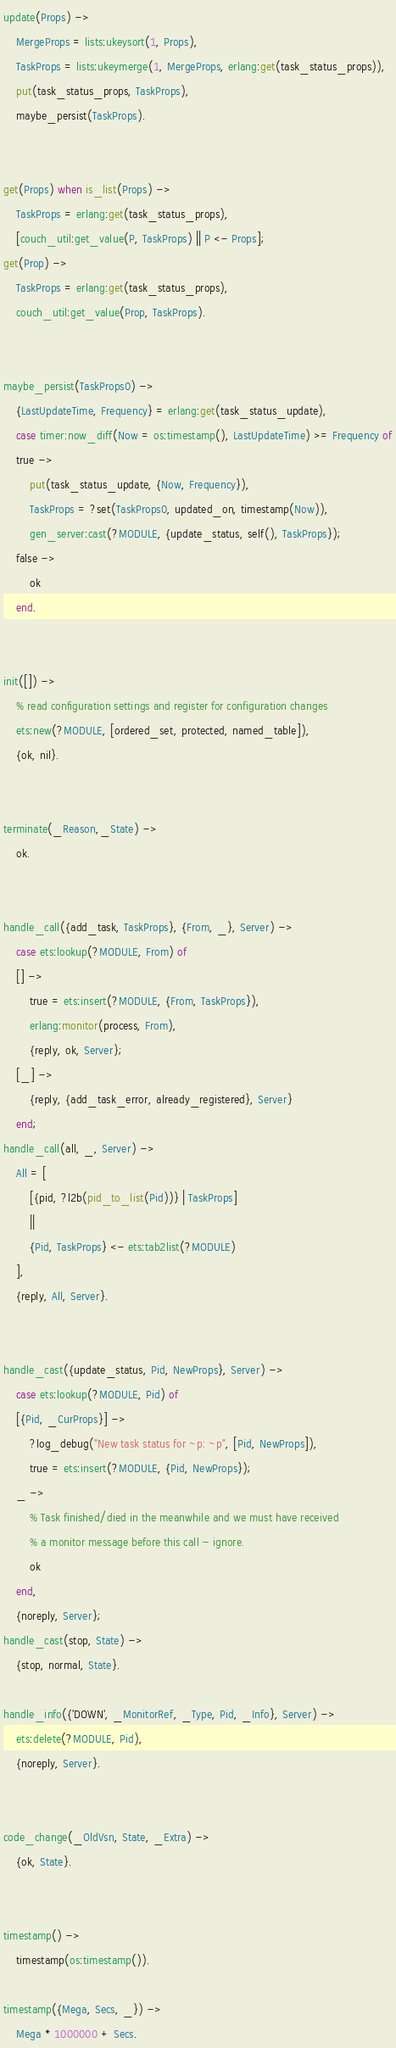<code> <loc_0><loc_0><loc_500><loc_500><_Erlang_>

update(Props) ->
    MergeProps = lists:ukeysort(1, Props),
    TaskProps = lists:ukeymerge(1, MergeProps, erlang:get(task_status_props)),
    put(task_status_props, TaskProps),
    maybe_persist(TaskProps).


get(Props) when is_list(Props) ->
    TaskProps = erlang:get(task_status_props),
    [couch_util:get_value(P, TaskProps) || P <- Props];
get(Prop) ->
    TaskProps = erlang:get(task_status_props),
    couch_util:get_value(Prop, TaskProps).


maybe_persist(TaskProps0) ->
    {LastUpdateTime, Frequency} = erlang:get(task_status_update),
    case timer:now_diff(Now = os:timestamp(), LastUpdateTime) >= Frequency of
    true ->
        put(task_status_update, {Now, Frequency}),
        TaskProps = ?set(TaskProps0, updated_on, timestamp(Now)),
        gen_server:cast(?MODULE, {update_status, self(), TaskProps});
    false ->
        ok
    end.


init([]) ->
    % read configuration settings and register for configuration changes
    ets:new(?MODULE, [ordered_set, protected, named_table]),
    {ok, nil}.


terminate(_Reason,_State) ->
    ok.


handle_call({add_task, TaskProps}, {From, _}, Server) ->
    case ets:lookup(?MODULE, From) of
    [] ->
        true = ets:insert(?MODULE, {From, TaskProps}),
        erlang:monitor(process, From),
        {reply, ok, Server};
    [_] ->
        {reply, {add_task_error, already_registered}, Server}
    end;
handle_call(all, _, Server) ->
    All = [
        [{pid, ?l2b(pid_to_list(Pid))} | TaskProps]
        ||
        {Pid, TaskProps} <- ets:tab2list(?MODULE)
    ],
    {reply, All, Server}.


handle_cast({update_status, Pid, NewProps}, Server) ->
    case ets:lookup(?MODULE, Pid) of
    [{Pid, _CurProps}] ->
        ?log_debug("New task status for ~p: ~p", [Pid, NewProps]),
        true = ets:insert(?MODULE, {Pid, NewProps});
    _ ->
        % Task finished/died in the meanwhile and we must have received
        % a monitor message before this call - ignore.
        ok
    end,
    {noreply, Server};
handle_cast(stop, State) ->
    {stop, normal, State}.

handle_info({'DOWN', _MonitorRef, _Type, Pid, _Info}, Server) ->
    ets:delete(?MODULE, Pid),
    {noreply, Server}.


code_change(_OldVsn, State, _Extra) ->
    {ok, State}.


timestamp() ->
    timestamp(os:timestamp()).

timestamp({Mega, Secs, _}) ->
    Mega * 1000000 + Secs.
</code> 